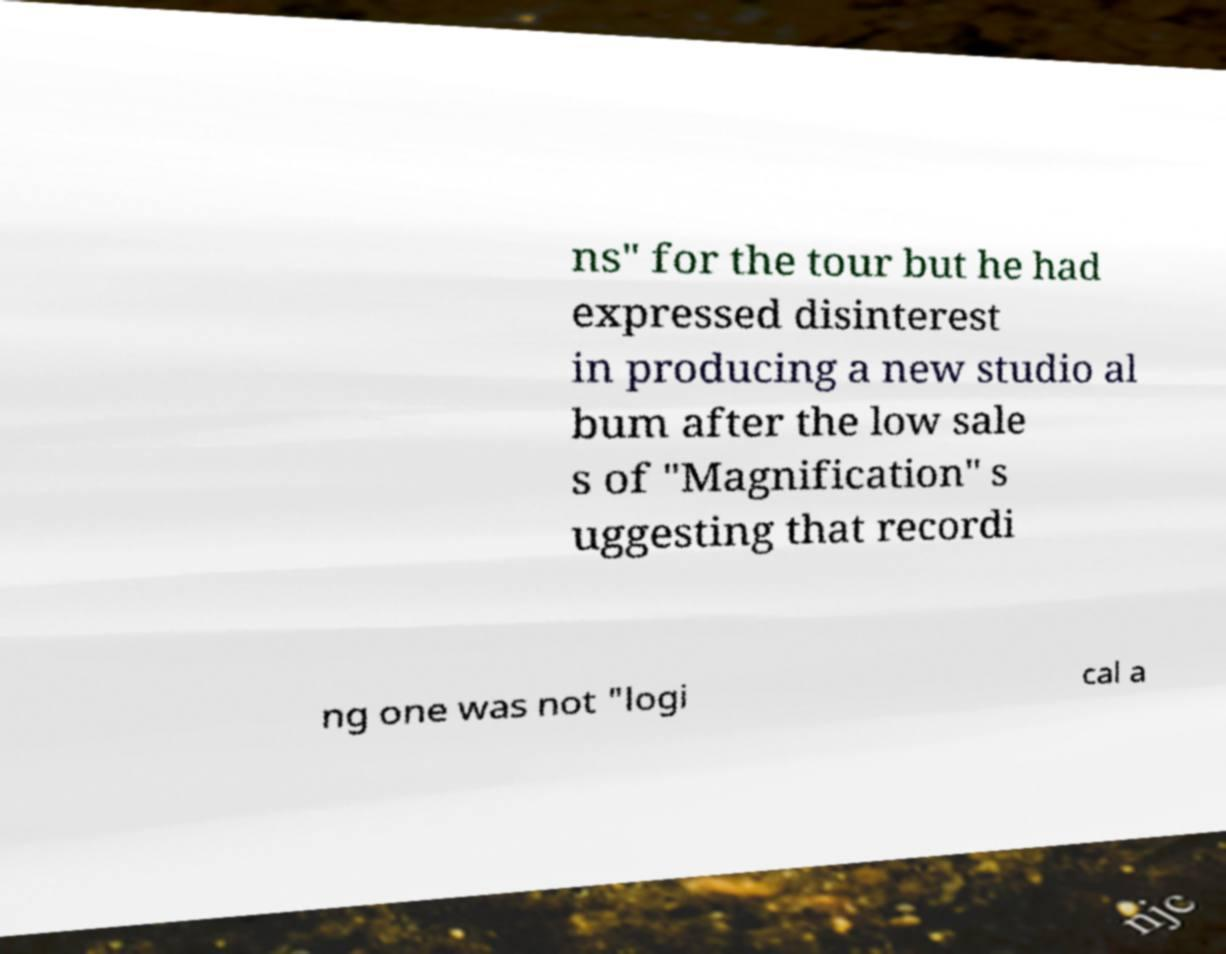Could you assist in decoding the text presented in this image and type it out clearly? ns" for the tour but he had expressed disinterest in producing a new studio al bum after the low sale s of "Magnification" s uggesting that recordi ng one was not "logi cal a 